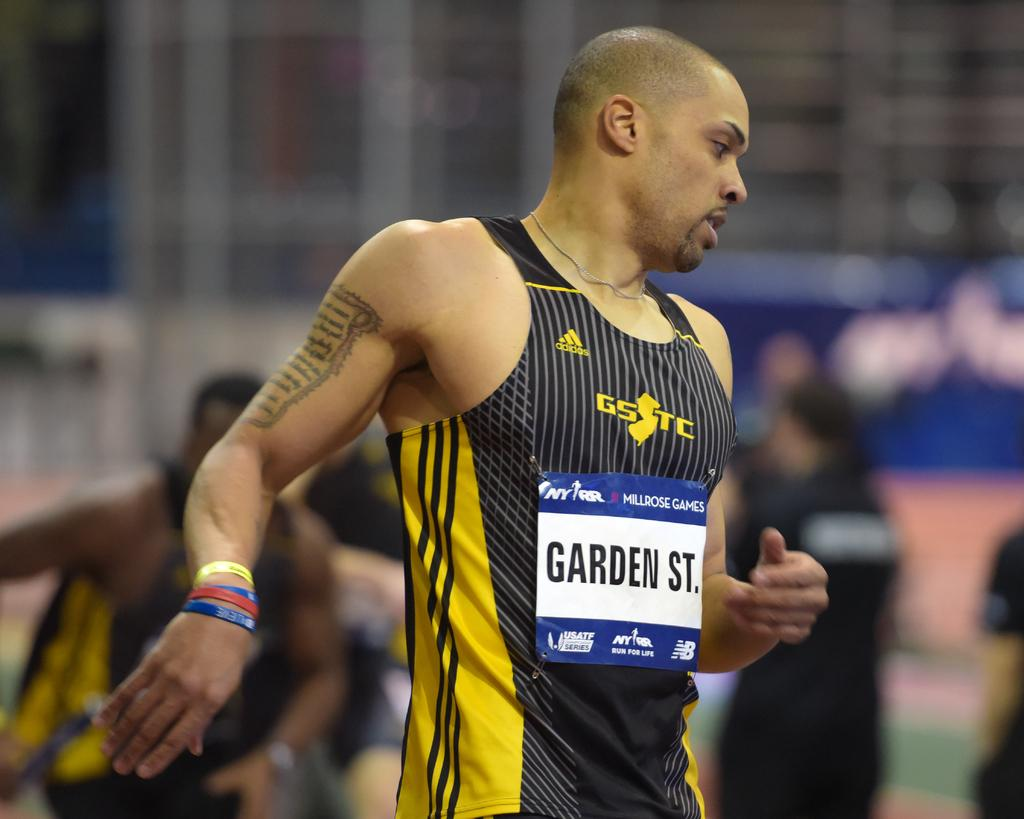<image>
Write a terse but informative summary of the picture. An athlete from Garden State competes in the Millrose Games. 